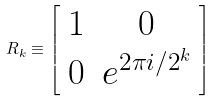Convert formula to latex. <formula><loc_0><loc_0><loc_500><loc_500>R _ { k } \equiv \left [ { \begin{array} { c c } 1 & 0 \\ 0 & e ^ { 2 \pi i / 2 ^ { k } } \\ \end{array} } \right ]</formula> 